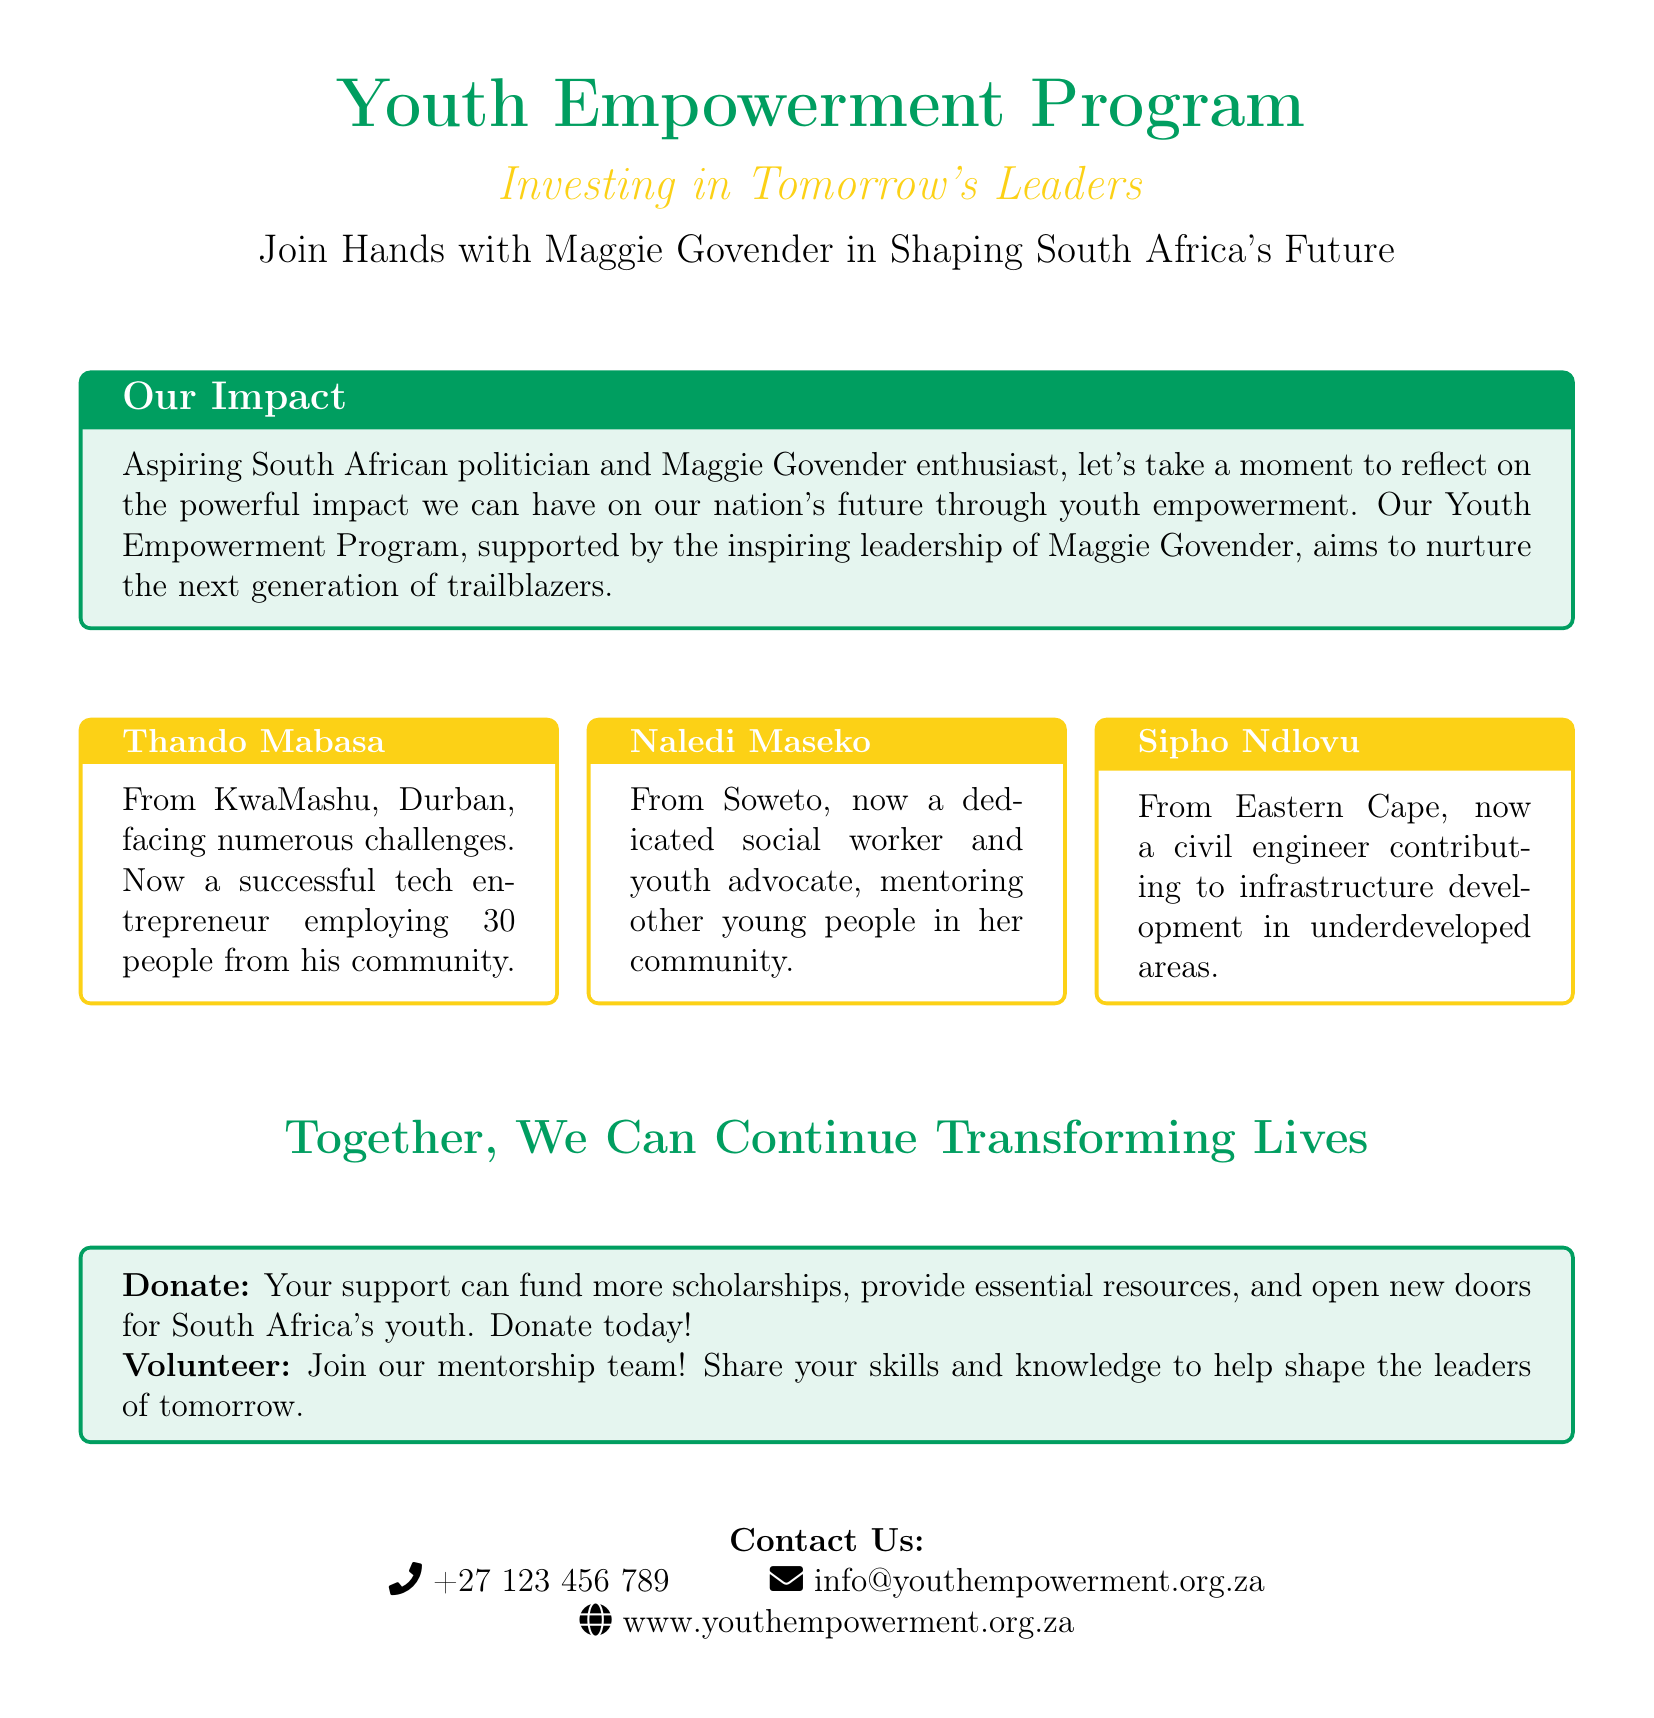What is the name of the program? The title of the program is prominently displayed in the document as "Youth Empowerment Program."
Answer: Youth Empowerment Program Who is the main supporter of the initiative? The document mentions Maggie Govender as the inspiring leadership behind the program.
Answer: Maggie Govender What is Thando Mabasa's current profession? Thando Mabasa is described as a successful tech entrepreneur in the document.
Answer: Tech entrepreneur Where does Naledi Maseko work? Naledi Maseko is described as a dedicated social worker and youth advocate in her community.
Answer: Social worker How many people does Thando employ? The information indicates that Thando Mabasa employs 30 people from his community.
Answer: 30 What is the call to action for supporters? The document encourages readers to donate or volunteer to support the program.
Answer: Donate or volunteer What color is used for the title of the program? The title "Youth Empowerment Program" is depicted in green.
Answer: Green What is one of Sipho Ndlovu's contributions? Sipho Ndlovu is contributing to infrastructure development in underdeveloped areas.
Answer: Infrastructure development 